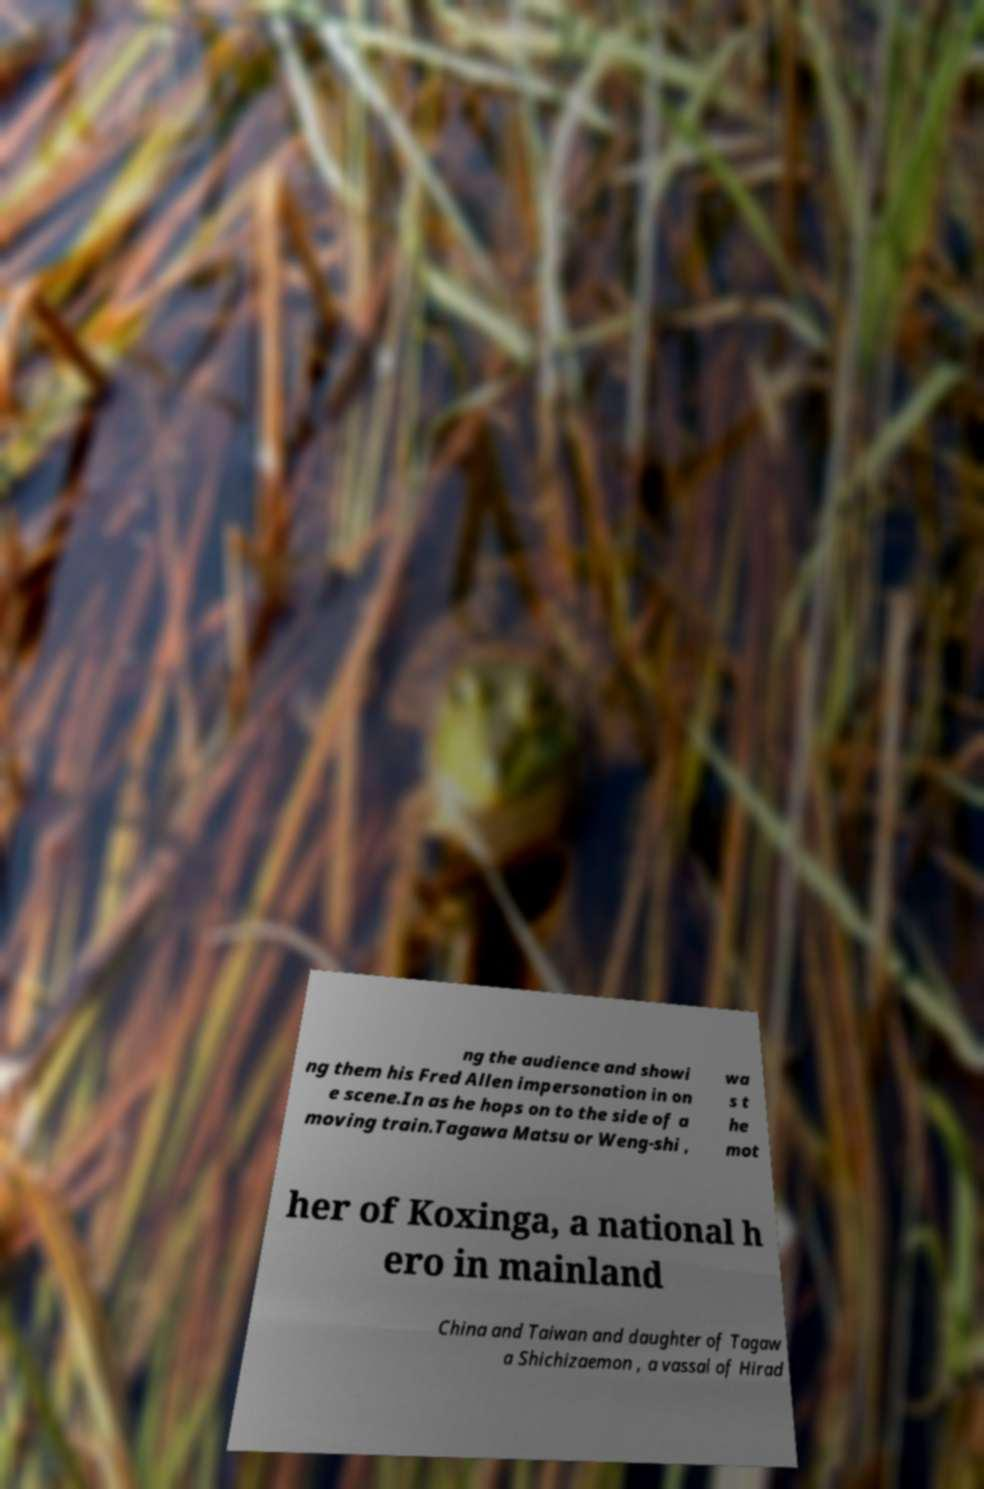Could you assist in decoding the text presented in this image and type it out clearly? ng the audience and showi ng them his Fred Allen impersonation in on e scene.In as he hops on to the side of a moving train.Tagawa Matsu or Weng-shi , wa s t he mot her of Koxinga, a national h ero in mainland China and Taiwan and daughter of Tagaw a Shichizaemon , a vassal of Hirad 